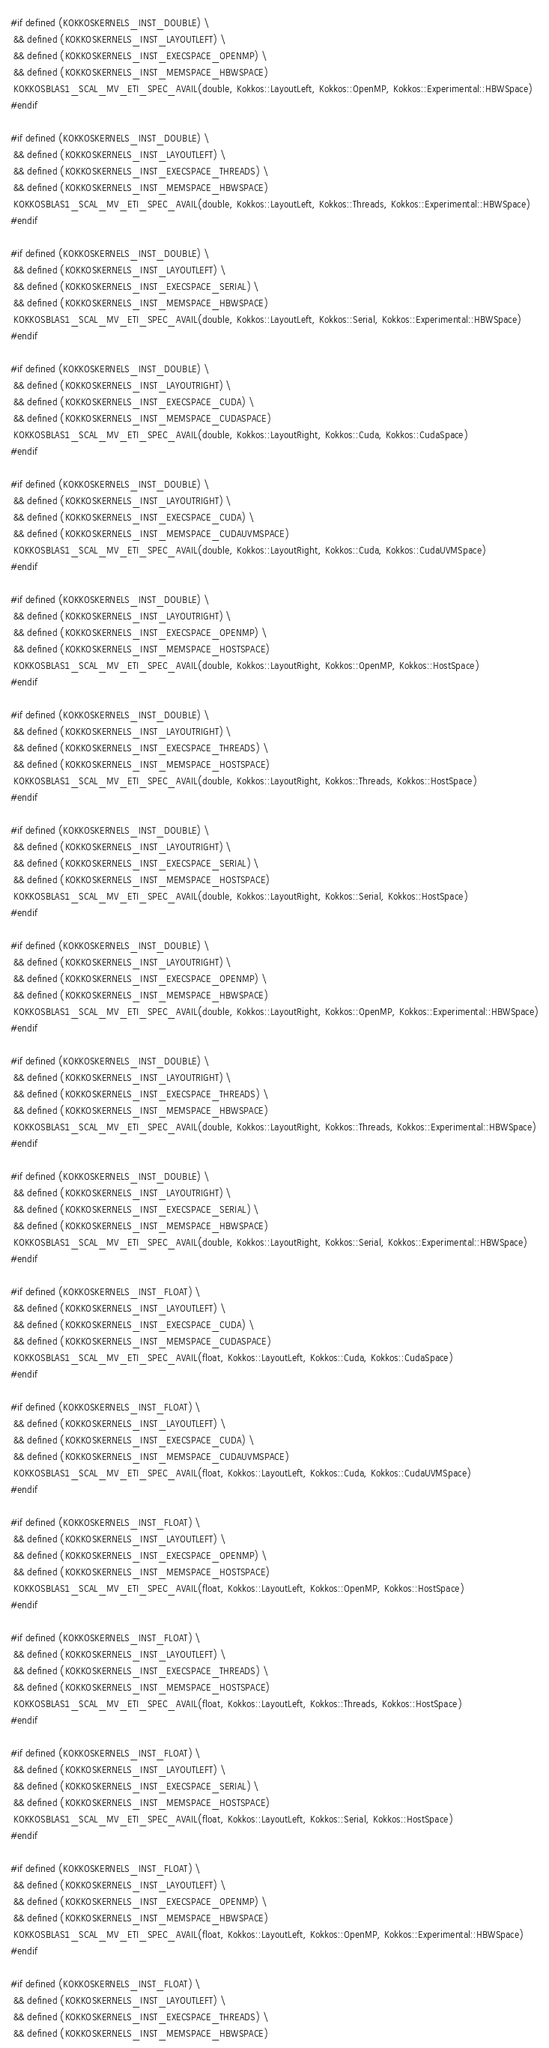<code> <loc_0><loc_0><loc_500><loc_500><_C++_>#if defined (KOKKOSKERNELS_INST_DOUBLE) \
 && defined (KOKKOSKERNELS_INST_LAYOUTLEFT) \
 && defined (KOKKOSKERNELS_INST_EXECSPACE_OPENMP) \
 && defined (KOKKOSKERNELS_INST_MEMSPACE_HBWSPACE)
 KOKKOSBLAS1_SCAL_MV_ETI_SPEC_AVAIL(double, Kokkos::LayoutLeft, Kokkos::OpenMP, Kokkos::Experimental::HBWSpace)
#endif

#if defined (KOKKOSKERNELS_INST_DOUBLE) \
 && defined (KOKKOSKERNELS_INST_LAYOUTLEFT) \
 && defined (KOKKOSKERNELS_INST_EXECSPACE_THREADS) \
 && defined (KOKKOSKERNELS_INST_MEMSPACE_HBWSPACE)
 KOKKOSBLAS1_SCAL_MV_ETI_SPEC_AVAIL(double, Kokkos::LayoutLeft, Kokkos::Threads, Kokkos::Experimental::HBWSpace)
#endif

#if defined (KOKKOSKERNELS_INST_DOUBLE) \
 && defined (KOKKOSKERNELS_INST_LAYOUTLEFT) \
 && defined (KOKKOSKERNELS_INST_EXECSPACE_SERIAL) \
 && defined (KOKKOSKERNELS_INST_MEMSPACE_HBWSPACE)
 KOKKOSBLAS1_SCAL_MV_ETI_SPEC_AVAIL(double, Kokkos::LayoutLeft, Kokkos::Serial, Kokkos::Experimental::HBWSpace)
#endif

#if defined (KOKKOSKERNELS_INST_DOUBLE) \
 && defined (KOKKOSKERNELS_INST_LAYOUTRIGHT) \
 && defined (KOKKOSKERNELS_INST_EXECSPACE_CUDA) \
 && defined (KOKKOSKERNELS_INST_MEMSPACE_CUDASPACE)
 KOKKOSBLAS1_SCAL_MV_ETI_SPEC_AVAIL(double, Kokkos::LayoutRight, Kokkos::Cuda, Kokkos::CudaSpace)
#endif

#if defined (KOKKOSKERNELS_INST_DOUBLE) \
 && defined (KOKKOSKERNELS_INST_LAYOUTRIGHT) \
 && defined (KOKKOSKERNELS_INST_EXECSPACE_CUDA) \
 && defined (KOKKOSKERNELS_INST_MEMSPACE_CUDAUVMSPACE)
 KOKKOSBLAS1_SCAL_MV_ETI_SPEC_AVAIL(double, Kokkos::LayoutRight, Kokkos::Cuda, Kokkos::CudaUVMSpace)
#endif

#if defined (KOKKOSKERNELS_INST_DOUBLE) \
 && defined (KOKKOSKERNELS_INST_LAYOUTRIGHT) \
 && defined (KOKKOSKERNELS_INST_EXECSPACE_OPENMP) \
 && defined (KOKKOSKERNELS_INST_MEMSPACE_HOSTSPACE)
 KOKKOSBLAS1_SCAL_MV_ETI_SPEC_AVAIL(double, Kokkos::LayoutRight, Kokkos::OpenMP, Kokkos::HostSpace)
#endif

#if defined (KOKKOSKERNELS_INST_DOUBLE) \
 && defined (KOKKOSKERNELS_INST_LAYOUTRIGHT) \
 && defined (KOKKOSKERNELS_INST_EXECSPACE_THREADS) \
 && defined (KOKKOSKERNELS_INST_MEMSPACE_HOSTSPACE)
 KOKKOSBLAS1_SCAL_MV_ETI_SPEC_AVAIL(double, Kokkos::LayoutRight, Kokkos::Threads, Kokkos::HostSpace)
#endif

#if defined (KOKKOSKERNELS_INST_DOUBLE) \
 && defined (KOKKOSKERNELS_INST_LAYOUTRIGHT) \
 && defined (KOKKOSKERNELS_INST_EXECSPACE_SERIAL) \
 && defined (KOKKOSKERNELS_INST_MEMSPACE_HOSTSPACE)
 KOKKOSBLAS1_SCAL_MV_ETI_SPEC_AVAIL(double, Kokkos::LayoutRight, Kokkos::Serial, Kokkos::HostSpace)
#endif

#if defined (KOKKOSKERNELS_INST_DOUBLE) \
 && defined (KOKKOSKERNELS_INST_LAYOUTRIGHT) \
 && defined (KOKKOSKERNELS_INST_EXECSPACE_OPENMP) \
 && defined (KOKKOSKERNELS_INST_MEMSPACE_HBWSPACE)
 KOKKOSBLAS1_SCAL_MV_ETI_SPEC_AVAIL(double, Kokkos::LayoutRight, Kokkos::OpenMP, Kokkos::Experimental::HBWSpace)
#endif

#if defined (KOKKOSKERNELS_INST_DOUBLE) \
 && defined (KOKKOSKERNELS_INST_LAYOUTRIGHT) \
 && defined (KOKKOSKERNELS_INST_EXECSPACE_THREADS) \
 && defined (KOKKOSKERNELS_INST_MEMSPACE_HBWSPACE)
 KOKKOSBLAS1_SCAL_MV_ETI_SPEC_AVAIL(double, Kokkos::LayoutRight, Kokkos::Threads, Kokkos::Experimental::HBWSpace)
#endif

#if defined (KOKKOSKERNELS_INST_DOUBLE) \
 && defined (KOKKOSKERNELS_INST_LAYOUTRIGHT) \
 && defined (KOKKOSKERNELS_INST_EXECSPACE_SERIAL) \
 && defined (KOKKOSKERNELS_INST_MEMSPACE_HBWSPACE)
 KOKKOSBLAS1_SCAL_MV_ETI_SPEC_AVAIL(double, Kokkos::LayoutRight, Kokkos::Serial, Kokkos::Experimental::HBWSpace)
#endif

#if defined (KOKKOSKERNELS_INST_FLOAT) \
 && defined (KOKKOSKERNELS_INST_LAYOUTLEFT) \
 && defined (KOKKOSKERNELS_INST_EXECSPACE_CUDA) \
 && defined (KOKKOSKERNELS_INST_MEMSPACE_CUDASPACE)
 KOKKOSBLAS1_SCAL_MV_ETI_SPEC_AVAIL(float, Kokkos::LayoutLeft, Kokkos::Cuda, Kokkos::CudaSpace)
#endif

#if defined (KOKKOSKERNELS_INST_FLOAT) \
 && defined (KOKKOSKERNELS_INST_LAYOUTLEFT) \
 && defined (KOKKOSKERNELS_INST_EXECSPACE_CUDA) \
 && defined (KOKKOSKERNELS_INST_MEMSPACE_CUDAUVMSPACE)
 KOKKOSBLAS1_SCAL_MV_ETI_SPEC_AVAIL(float, Kokkos::LayoutLeft, Kokkos::Cuda, Kokkos::CudaUVMSpace)
#endif

#if defined (KOKKOSKERNELS_INST_FLOAT) \
 && defined (KOKKOSKERNELS_INST_LAYOUTLEFT) \
 && defined (KOKKOSKERNELS_INST_EXECSPACE_OPENMP) \
 && defined (KOKKOSKERNELS_INST_MEMSPACE_HOSTSPACE)
 KOKKOSBLAS1_SCAL_MV_ETI_SPEC_AVAIL(float, Kokkos::LayoutLeft, Kokkos::OpenMP, Kokkos::HostSpace)
#endif

#if defined (KOKKOSKERNELS_INST_FLOAT) \
 && defined (KOKKOSKERNELS_INST_LAYOUTLEFT) \
 && defined (KOKKOSKERNELS_INST_EXECSPACE_THREADS) \
 && defined (KOKKOSKERNELS_INST_MEMSPACE_HOSTSPACE)
 KOKKOSBLAS1_SCAL_MV_ETI_SPEC_AVAIL(float, Kokkos::LayoutLeft, Kokkos::Threads, Kokkos::HostSpace)
#endif

#if defined (KOKKOSKERNELS_INST_FLOAT) \
 && defined (KOKKOSKERNELS_INST_LAYOUTLEFT) \
 && defined (KOKKOSKERNELS_INST_EXECSPACE_SERIAL) \
 && defined (KOKKOSKERNELS_INST_MEMSPACE_HOSTSPACE)
 KOKKOSBLAS1_SCAL_MV_ETI_SPEC_AVAIL(float, Kokkos::LayoutLeft, Kokkos::Serial, Kokkos::HostSpace)
#endif

#if defined (KOKKOSKERNELS_INST_FLOAT) \
 && defined (KOKKOSKERNELS_INST_LAYOUTLEFT) \
 && defined (KOKKOSKERNELS_INST_EXECSPACE_OPENMP) \
 && defined (KOKKOSKERNELS_INST_MEMSPACE_HBWSPACE)
 KOKKOSBLAS1_SCAL_MV_ETI_SPEC_AVAIL(float, Kokkos::LayoutLeft, Kokkos::OpenMP, Kokkos::Experimental::HBWSpace)
#endif

#if defined (KOKKOSKERNELS_INST_FLOAT) \
 && defined (KOKKOSKERNELS_INST_LAYOUTLEFT) \
 && defined (KOKKOSKERNELS_INST_EXECSPACE_THREADS) \
 && defined (KOKKOSKERNELS_INST_MEMSPACE_HBWSPACE)</code> 